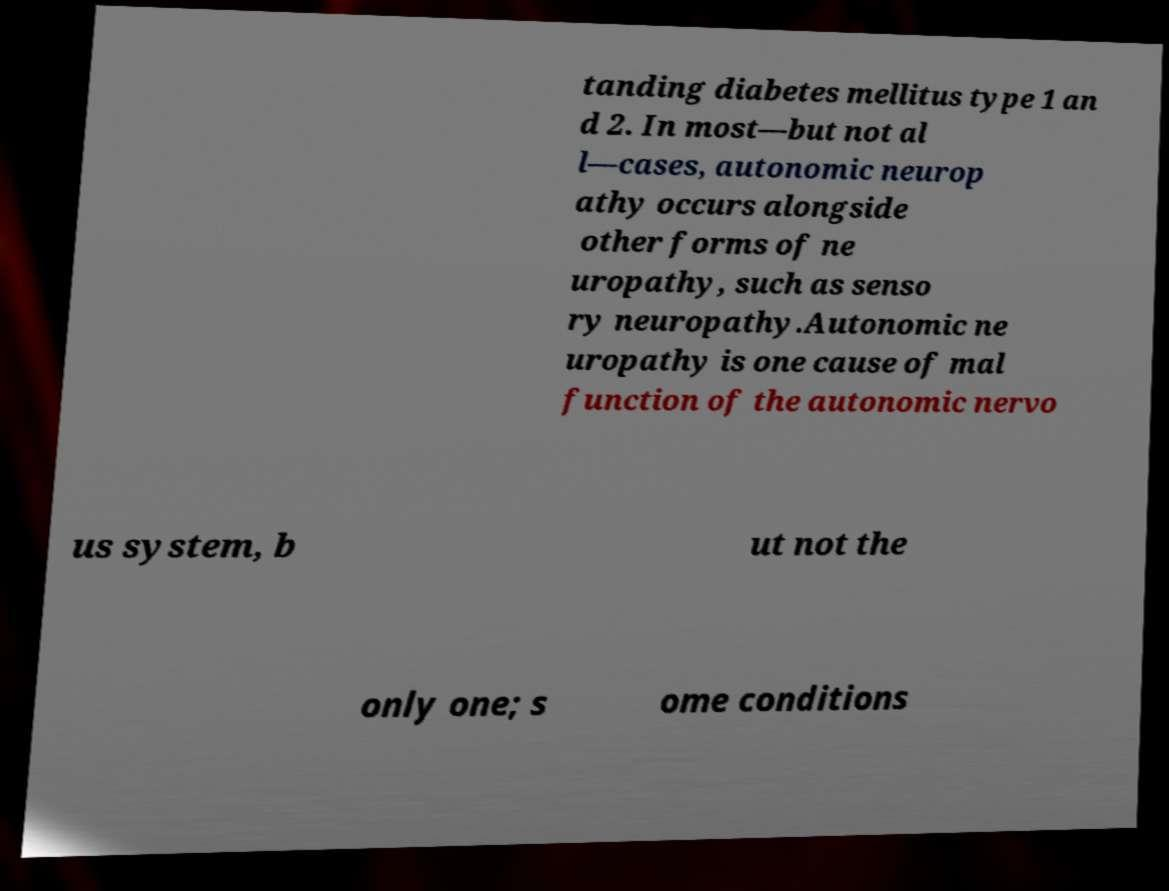What messages or text are displayed in this image? I need them in a readable, typed format. tanding diabetes mellitus type 1 an d 2. In most—but not al l—cases, autonomic neurop athy occurs alongside other forms of ne uropathy, such as senso ry neuropathy.Autonomic ne uropathy is one cause of mal function of the autonomic nervo us system, b ut not the only one; s ome conditions 